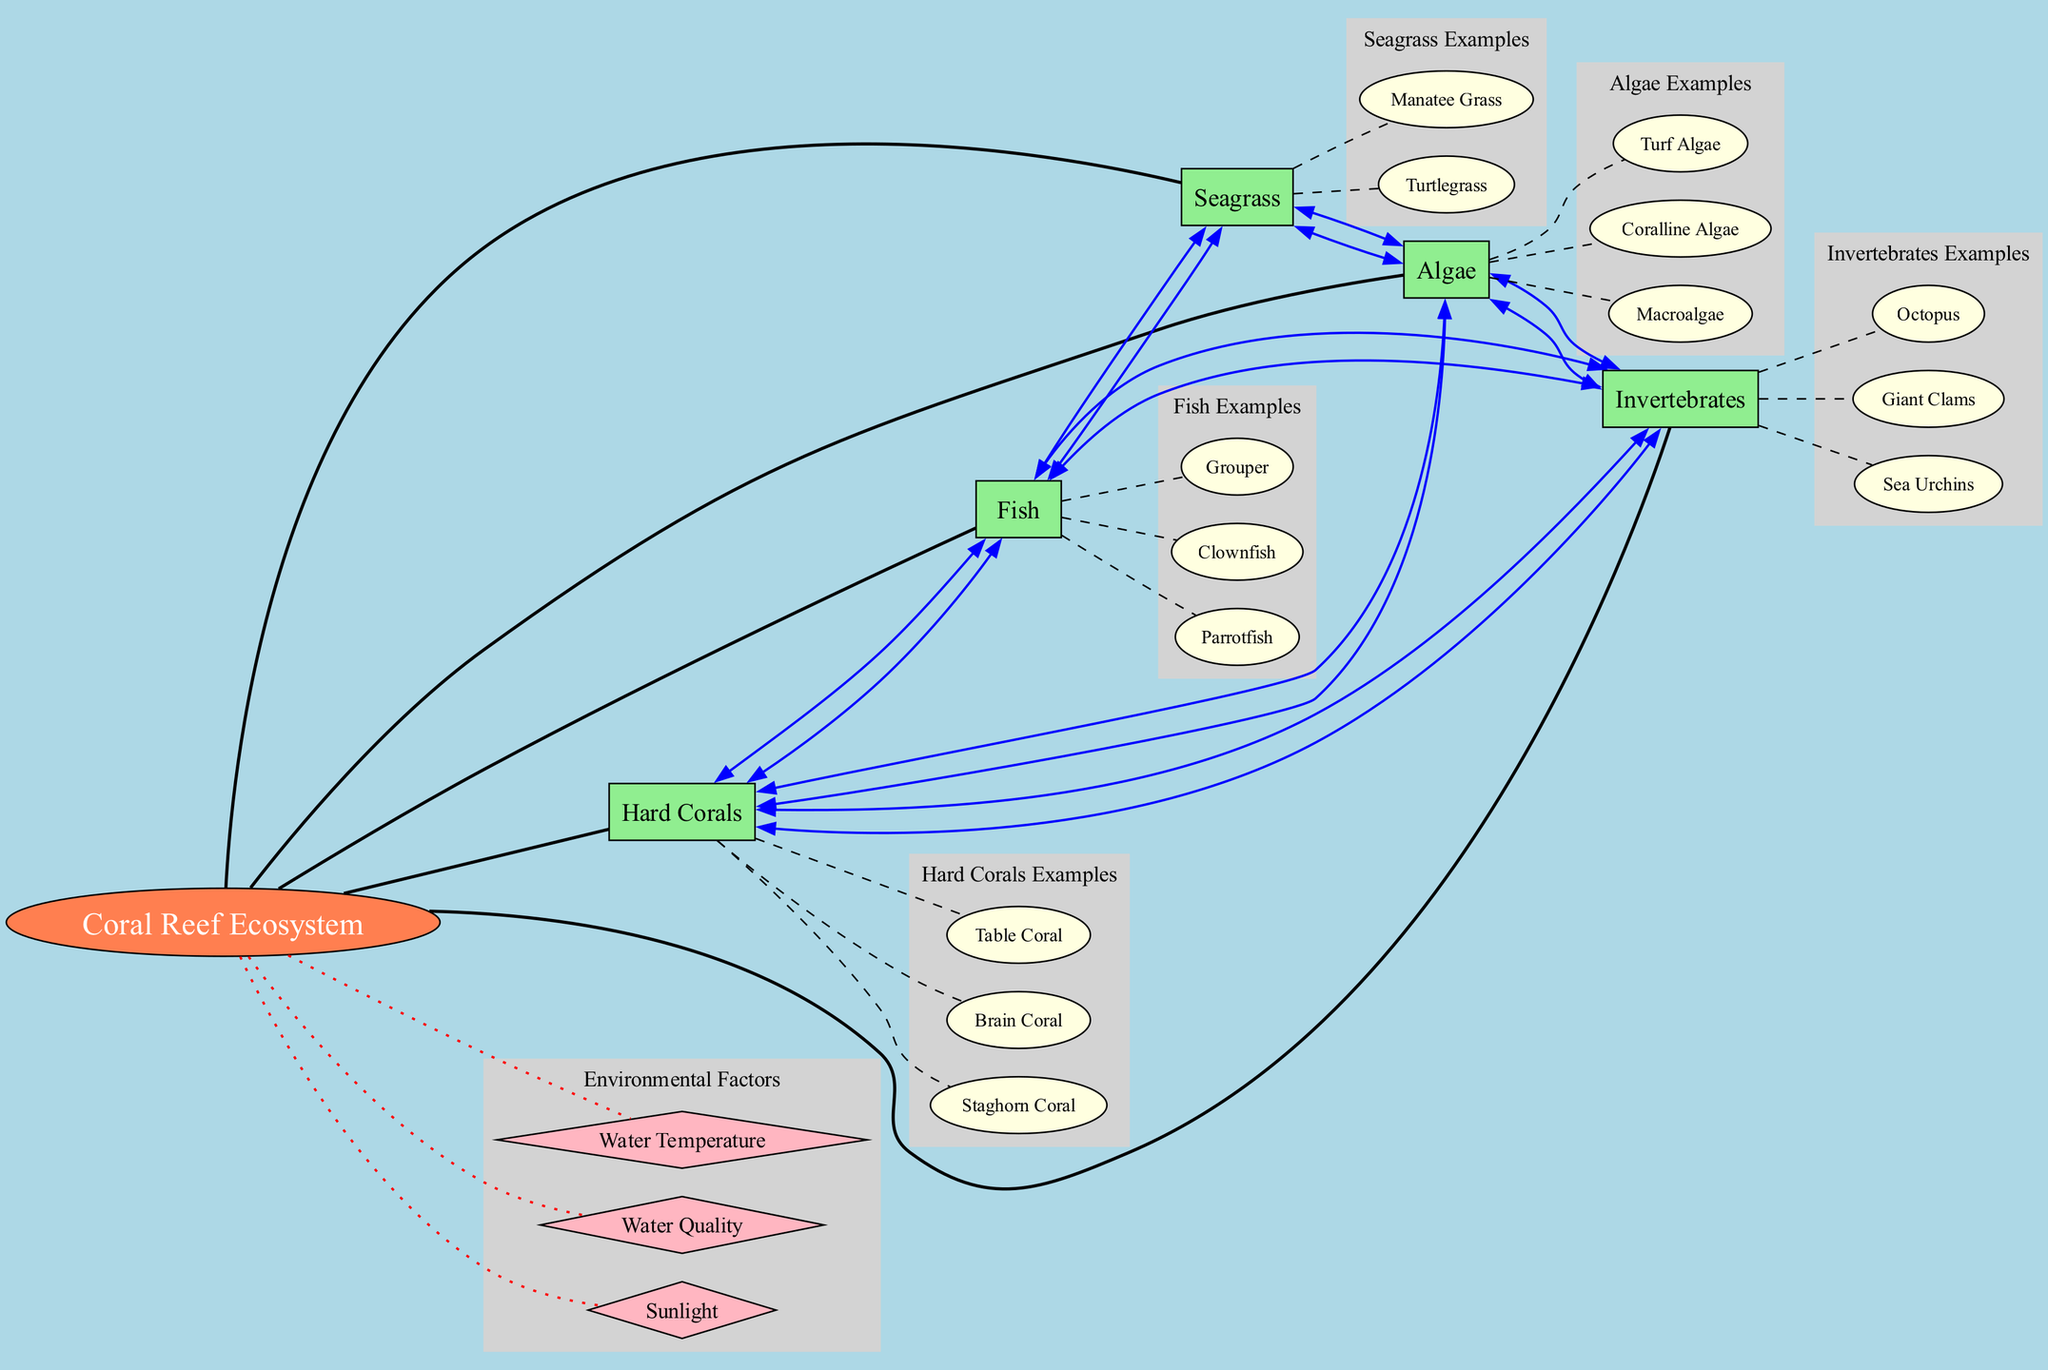What are the examples of Hard Corals? The diagram lists examples of Hard Corals. By locating the Hard Corals node and looking at its subgraph, the examples provided are Staghorn Coral, Brain Coral, and Table Coral.
Answer: Staghorn Coral, Brain Coral, Table Coral How many main components are there in the Coral Reef Ecosystem? By counting the number of nodes directly connected to the center node labeled "Coral Reef Ecosystem," we can determine that there are five main components: Hard Corals, Fish, Invertebrates, Algae, and Seagrass.
Answer: 5 Which components are connected to Fish? To answer this, we examine the Fish node and look for its connections. The diagram shows that Fish is connected to Hard Corals, Invertebrates, and Seagrass.
Answer: Hard Corals, Invertebrates, Seagrass What type of node is the Coral Reef Ecosystem? The Coral Reef Ecosystem node is represented as an ellipse according to the diagram, indicating it serves as the center or core part of the ecosystem.
Answer: Ellipse What is the color of the Environmental Factors nodes? By inspecting the diagram, we note that the Environmental Factors are represented as diamond-shaped nodes, which are filled with light pink color.
Answer: Light pink Which component is connected to both Hard Corals and Algae? By checking the connections of both Hard Corals and Algae, we find that Invertebrates have edges leading to both nodes, establishing that it is the common component connected to both.
Answer: Invertebrates How many examples are listed under Invertebrates? The Invertebrates subgraph lists three examples: Sea Urchins, Giant Clams, and Octopus. Counting these instances leads us to determine that there are three examples provided.
Answer: 3 What environmental factor is represented as a dotted edge? The edges connecting the Environmental Factors to the Coral Reef Ecosystem are marked with a dotted line, indicating their lesser, supportive role in comparison to other connections. In the diagram, each defined environmental factor shows this style.
Answer: Environmental Factors What shape represents Seagrass? The Seagrass node in the diagram is shaped as a box, indicating its role in the ecosystem hierarchy as a main component alongside others like Fish and Algae.
Answer: Box 